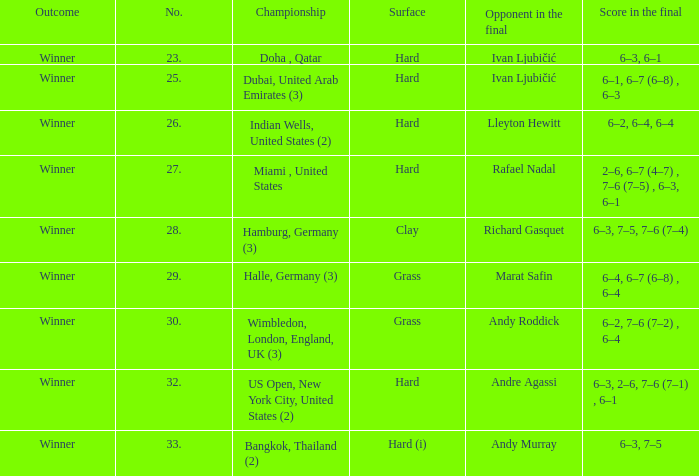Andy Roddick is the opponent in the final on what surface? Grass. 